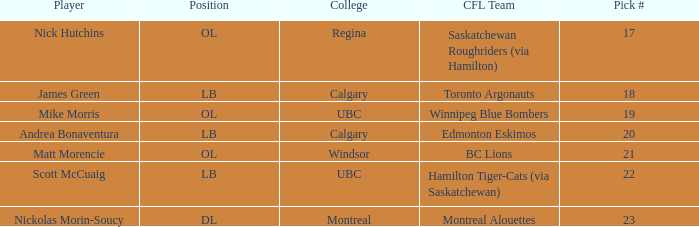What number picks were the players who went to Calgary?  18, 20. 